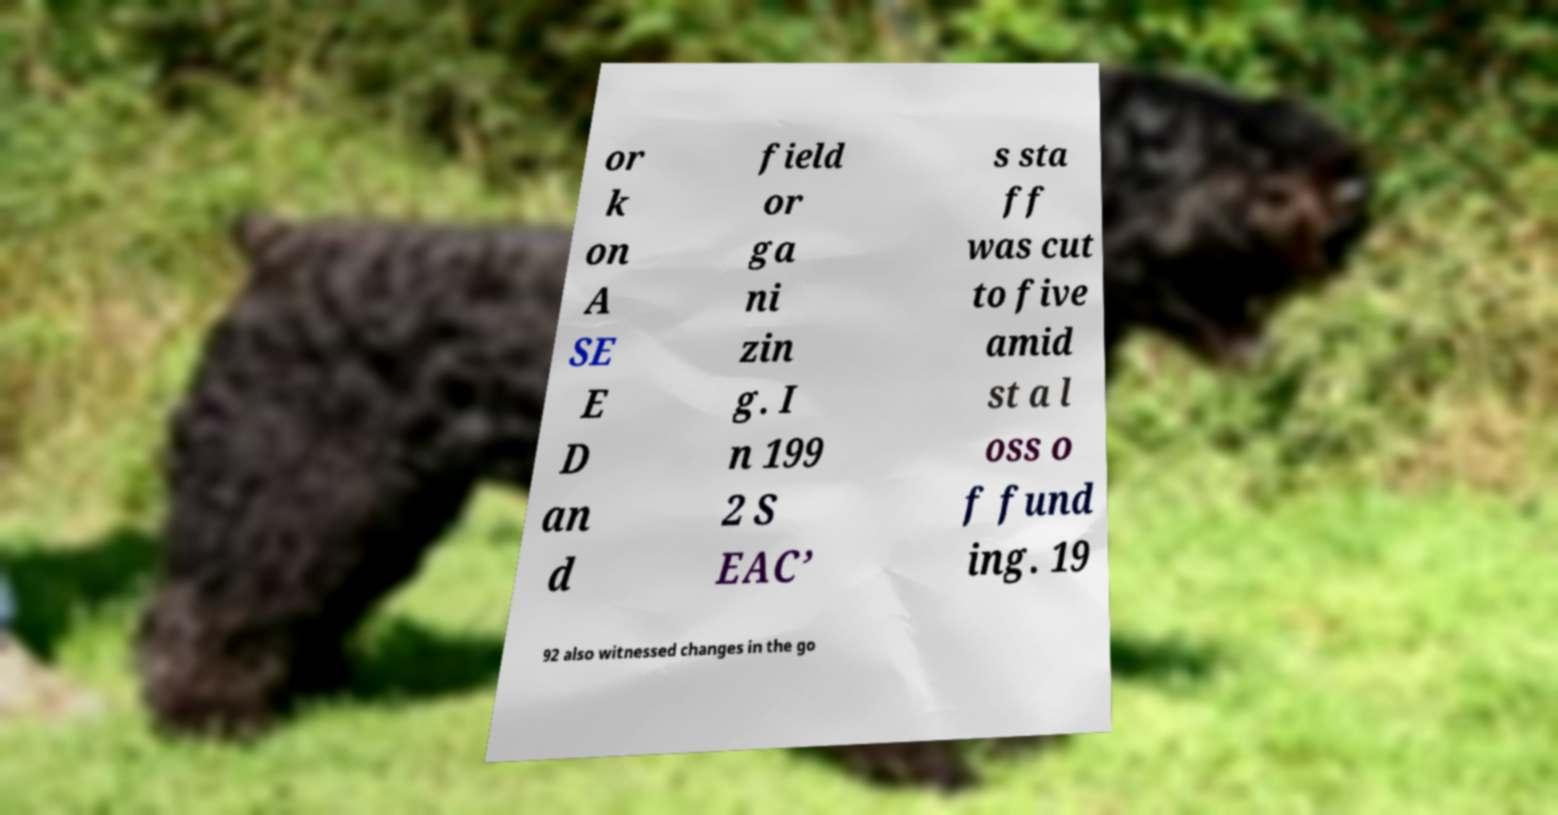Could you assist in decoding the text presented in this image and type it out clearly? or k on A SE E D an d field or ga ni zin g. I n 199 2 S EAC’ s sta ff was cut to five amid st a l oss o f fund ing. 19 92 also witnessed changes in the go 